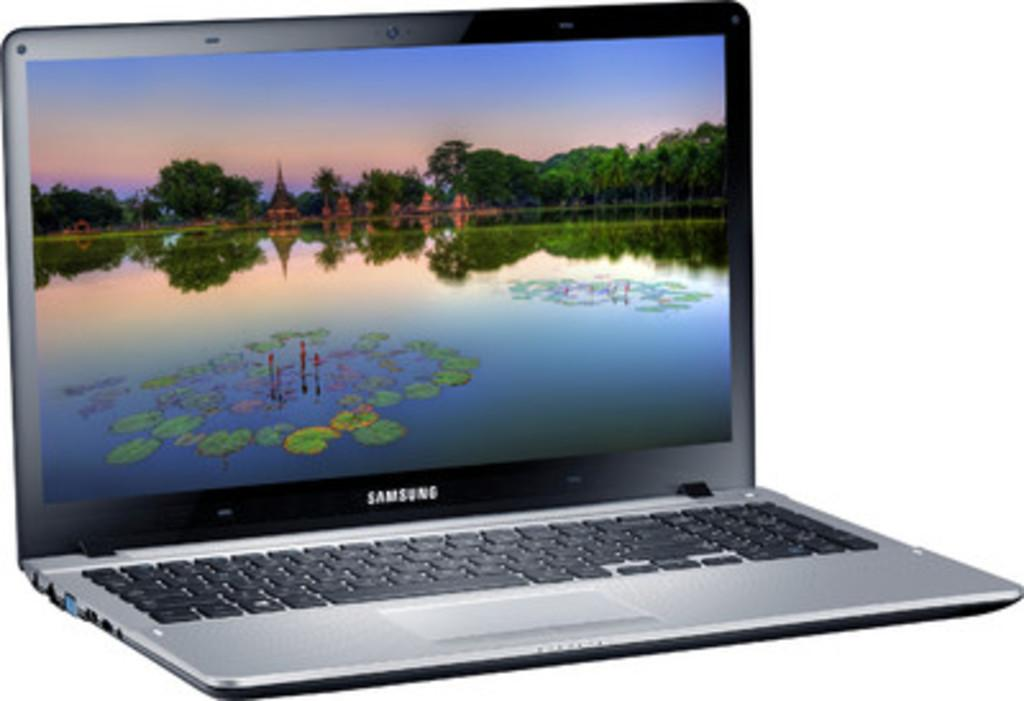<image>
Write a terse but informative summary of the picture. An open Samsung laptop with a scene of a lake and some type of buildings on the screen. 